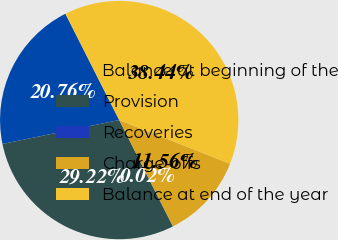Convert chart to OTSL. <chart><loc_0><loc_0><loc_500><loc_500><pie_chart><fcel>Balance at beginning of the<fcel>Provision<fcel>Recoveries<fcel>Charge-offs<fcel>Balance at end of the year<nl><fcel>20.76%<fcel>29.22%<fcel>0.02%<fcel>11.56%<fcel>38.44%<nl></chart> 